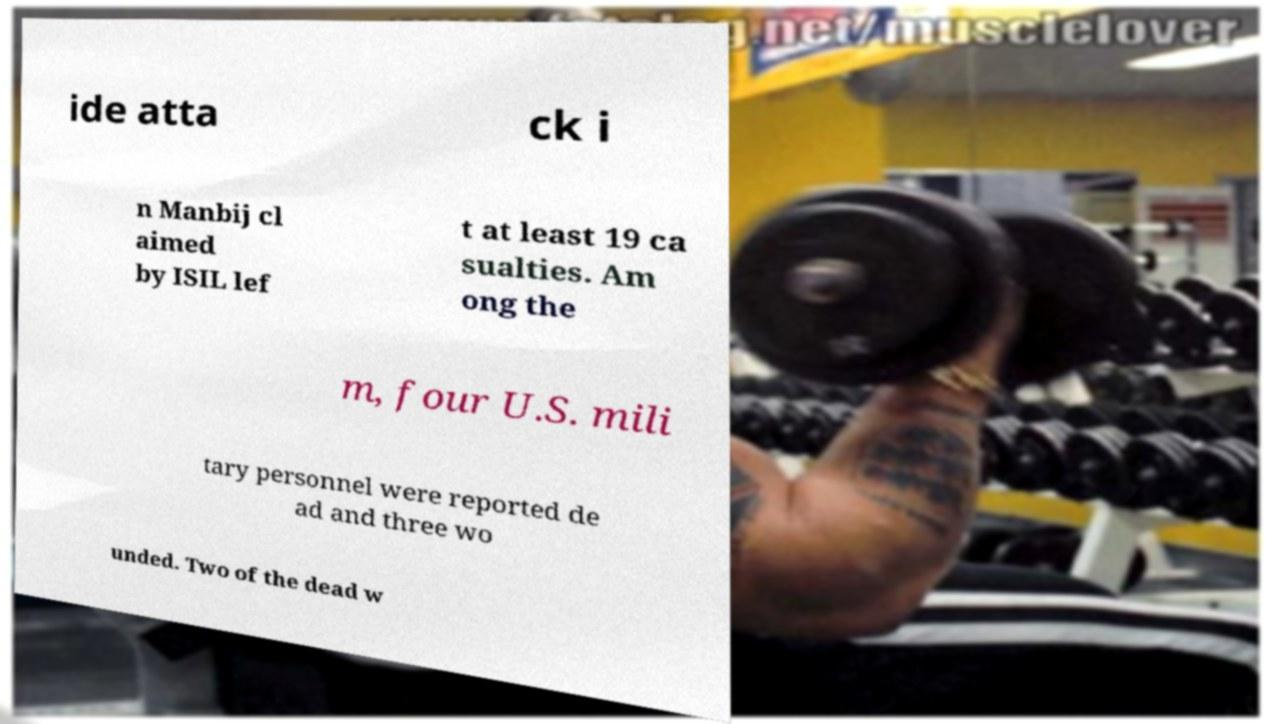Can you accurately transcribe the text from the provided image for me? ide atta ck i n Manbij cl aimed by ISIL lef t at least 19 ca sualties. Am ong the m, four U.S. mili tary personnel were reported de ad and three wo unded. Two of the dead w 